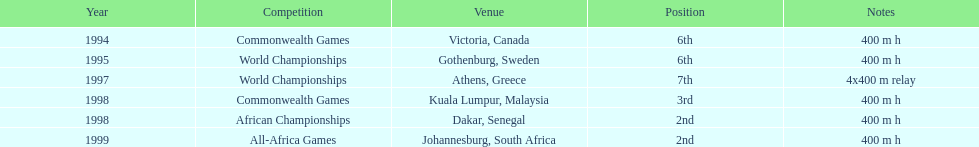After athens, greece, which location was chosen next? Kuala Lumpur, Malaysia. 